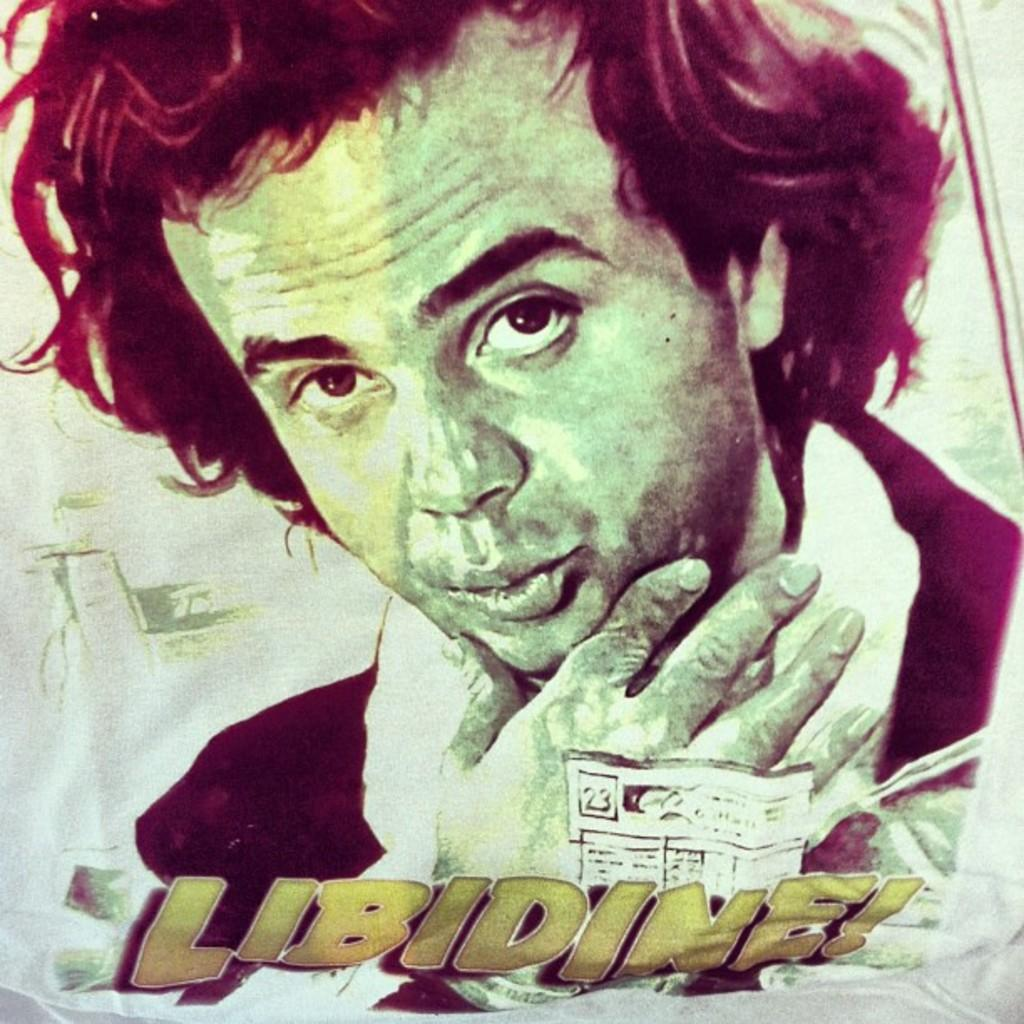Who is featured in the image? There is a man in the image. What is the context of the man's presence in the image? The man is part of a poster. What additional information can be found at the bottom of the image? There is text at the bottom of the image. What type of pig can be seen holding a quill in the image? There is no pig or quill present in the image; it features a man as part of a poster. 